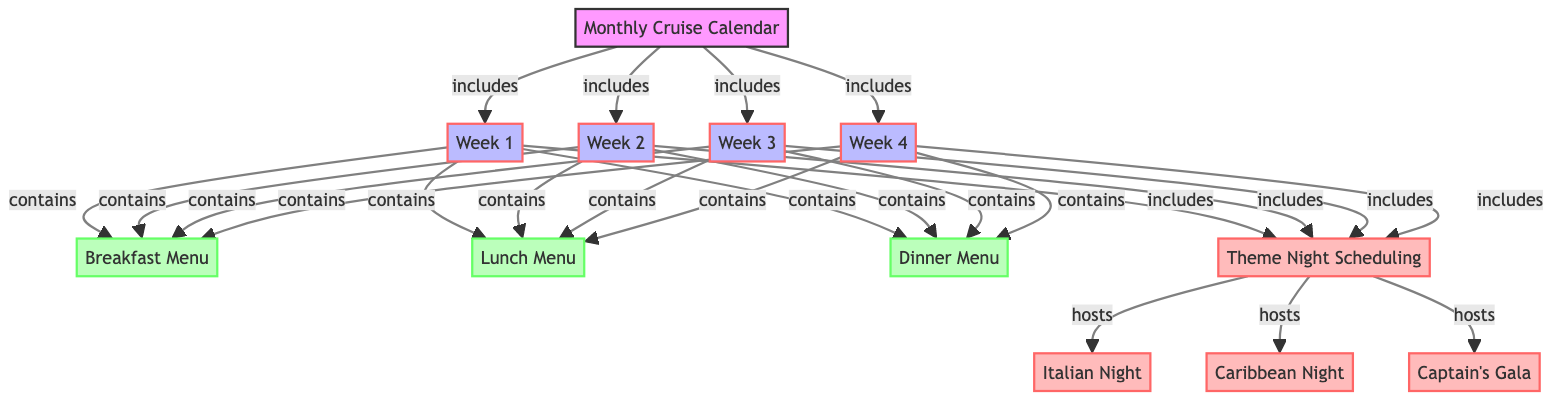What are the menus included in the Monthly Cruise Calendar? The diagram shows three menus associated with the Monthly Cruise Calendar: Breakfast Menu, Lunch Menu, and Dinner Menu. Each of these menus is connected to the four weeks in the calendar as part of the overall dining services structure.
Answer: Breakfast Menu, Lunch Menu, Dinner Menu How many theme nights are scheduled in the diagram? The diagram lists three theme nights: Italian Night, Caribbean Night, and Captain's Gala. Each of these theme nights is hosted under the Theme Night Scheduling node, which is linked to the weekly structure.
Answer: 3 Which week does the Dinner Menu fall under? The Dinner Menu is shown to be part of each of the four weeks (Week 1, Week 2, Week 3, Week 4) in the Monthly Cruise Calendar. It is connected directly to all weeks without exclusion.
Answer: Week 1, Week 2, Week 3, Week 4 What does the Theme Night Scheduling node connect to? The Theme Night Scheduling node connects to three specific theme nights: Italian Night, Caribbean Night, and Captain's Gala. This connection illustrates that all theme nights are planned within the framework of the dining schedule.
Answer: Italian Night, Caribbean Night, Captain's Gala Which week does not include a theme night? Each week in the Monthly Cruise Calendar includes the Theme Night Scheduling node, so all weeks are capable of having theme nights scheduled. Thus, there is no week without a potential theme night.
Answer: None What is the primary focus of the diagram? The primary focus of the diagram is to illustrate the relationship between the Monthly Cruise Calendar, the menus, and the theme night scheduling. It visually represents the organization of dining services in a cruise line's operational structure.
Answer: Menu Planning and Theme Night Scheduling 